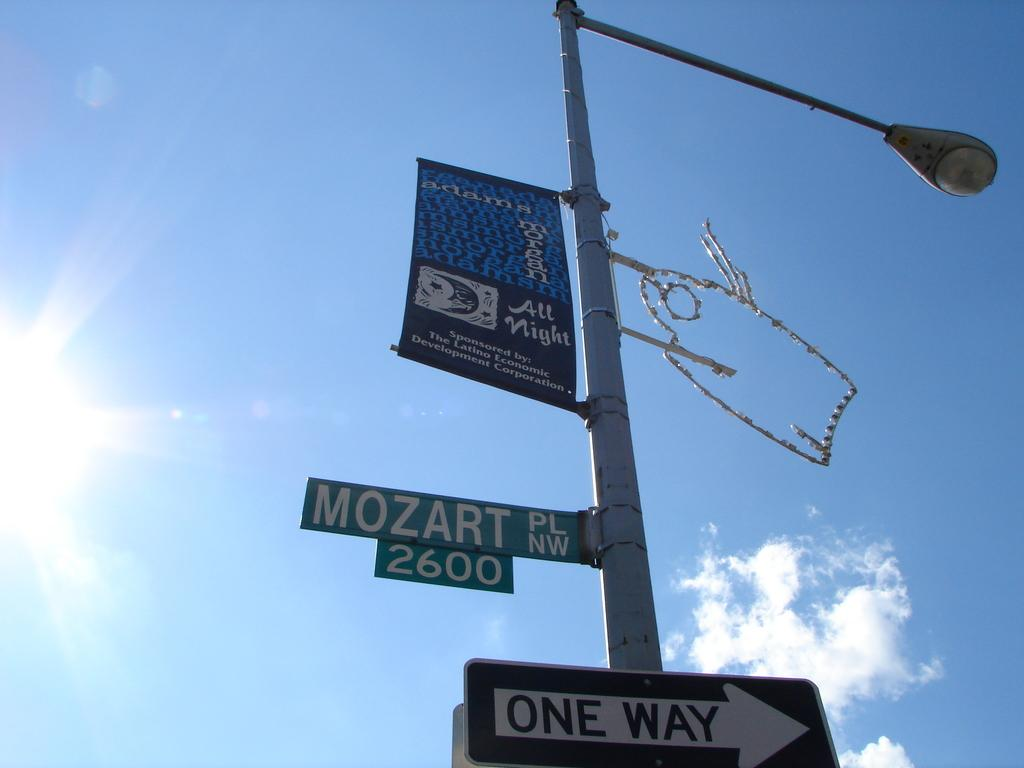<image>
Write a terse but informative summary of the picture. A sign on a lamp post tells traffic that it is One Way. 